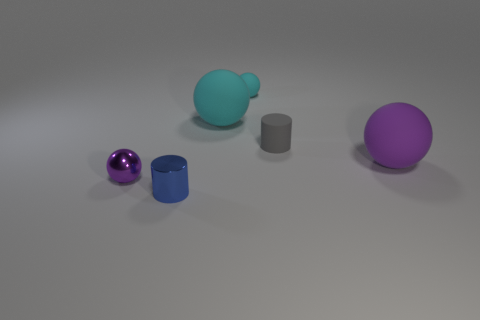Subtract all large purple matte balls. How many balls are left? 3 Subtract all cylinders. How many objects are left? 4 Add 2 tiny cyan rubber objects. How many objects exist? 8 Add 5 large red matte cylinders. How many large red matte cylinders exist? 5 Subtract all gray cylinders. How many cylinders are left? 1 Subtract 0 red cylinders. How many objects are left? 6 Subtract 2 cylinders. How many cylinders are left? 0 Subtract all gray spheres. Subtract all blue cubes. How many spheres are left? 4 Subtract all yellow cylinders. How many gray balls are left? 0 Subtract all cyan rubber balls. Subtract all tiny gray cylinders. How many objects are left? 3 